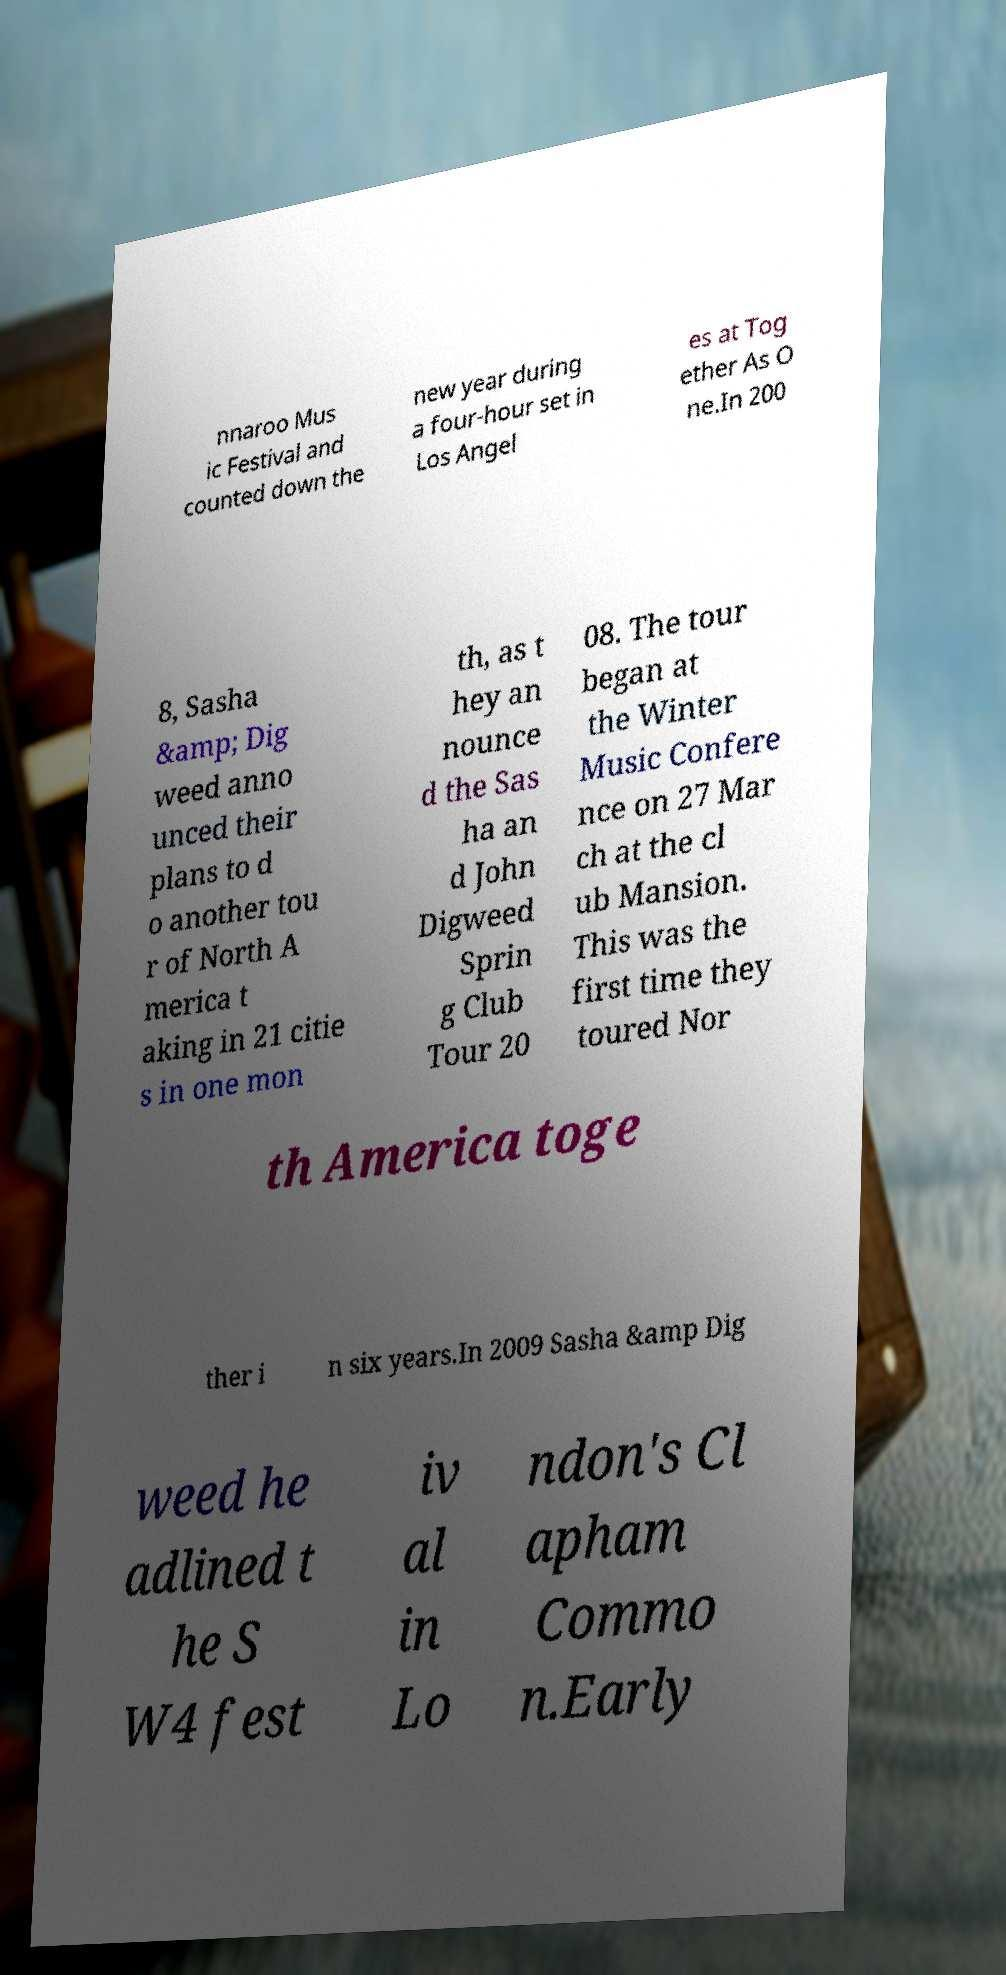Could you extract and type out the text from this image? nnaroo Mus ic Festival and counted down the new year during a four-hour set in Los Angel es at Tog ether As O ne.In 200 8, Sasha &amp; Dig weed anno unced their plans to d o another tou r of North A merica t aking in 21 citie s in one mon th, as t hey an nounce d the Sas ha an d John Digweed Sprin g Club Tour 20 08. The tour began at the Winter Music Confere nce on 27 Mar ch at the cl ub Mansion. This was the first time they toured Nor th America toge ther i n six years.In 2009 Sasha &amp Dig weed he adlined t he S W4 fest iv al in Lo ndon's Cl apham Commo n.Early 